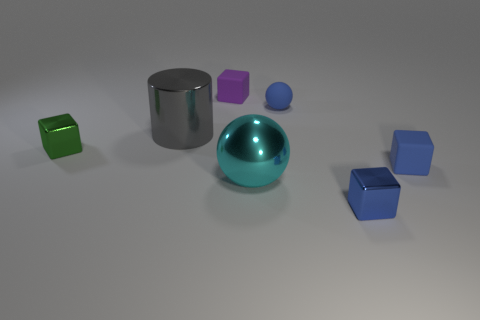Are there more big metallic balls than big shiny things?
Offer a terse response. No. How big is the block that is left of the cyan ball and to the right of the big gray object?
Your answer should be compact. Small. The gray object has what shape?
Your answer should be very brief. Cylinder. Is there anything else that is the same size as the rubber ball?
Keep it short and to the point. Yes. Is the number of purple matte things that are in front of the tiny blue metal thing greater than the number of matte cubes?
Ensure brevity in your answer.  No. What is the shape of the tiny shiny object left of the tiny matte block that is behind the tiny metallic block to the left of the blue shiny thing?
Give a very brief answer. Cube. Do the shiny thing to the left of the gray metallic object and the big cyan sphere have the same size?
Your answer should be compact. No. What shape is the metal object that is on the left side of the blue matte ball and right of the gray shiny cylinder?
Provide a succinct answer. Sphere. There is a small sphere; is its color the same as the rubber block that is in front of the small green cube?
Offer a terse response. Yes. There is a small block in front of the matte cube that is in front of the tiny thing left of the big metallic cylinder; what is its color?
Make the answer very short. Blue. 